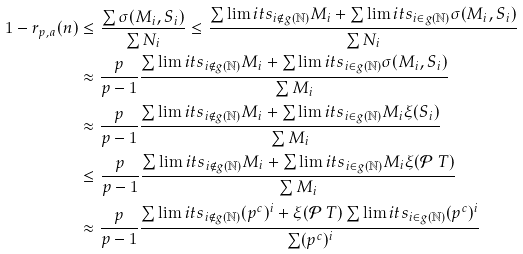<formula> <loc_0><loc_0><loc_500><loc_500>1 - r _ { p , a } ( n ) & \leq \frac { \sum \sigma ( M _ { i } , S _ { i } ) } { \sum N _ { i } } \leq \frac { \sum \lim i t s _ { i \notin g ( \mathbb { N } ) } M _ { i } + \sum \lim i t s _ { i \in g ( \mathbb { N } ) } \sigma ( M _ { i } , S _ { i } ) } { \sum N _ { i } } \\ & \approx \frac { p } { p - 1 } \frac { \sum \lim i t s _ { i \notin g ( \mathbb { N } ) } M _ { i } + \sum \lim i t s _ { i \in g ( \mathbb { N } ) } \sigma ( M _ { i } , S _ { i } ) } { \sum M _ { i } } \\ & \approx \frac { p } { p - 1 } \frac { \sum \lim i t s _ { i \notin g ( \mathbb { N } ) } M _ { i } + \sum \lim i t s _ { i \in g ( \mathbb { N } ) } M _ { i } \xi ( S _ { i } ) } { \sum M _ { i } } \\ & \leq \frac { p } { p - 1 } \frac { \sum \lim i t s _ { i \notin g ( \mathbb { N } ) } M _ { i } + \sum \lim i t s _ { i \in g ( \mathbb { N } ) } M _ { i } \xi ( \mathcal { P } \ T ) } { \sum M _ { i } } \\ & \approx \frac { p } { p - 1 } \frac { \sum \lim i t s _ { i \notin g ( \mathbb { N } ) } ( p ^ { c } ) ^ { i } + \xi ( \mathcal { P } \ T ) \sum \lim i t s _ { i \in g ( \mathbb { N } ) } ( p ^ { c } ) ^ { i } } { \sum ( p ^ { c } ) ^ { i } } \\</formula> 